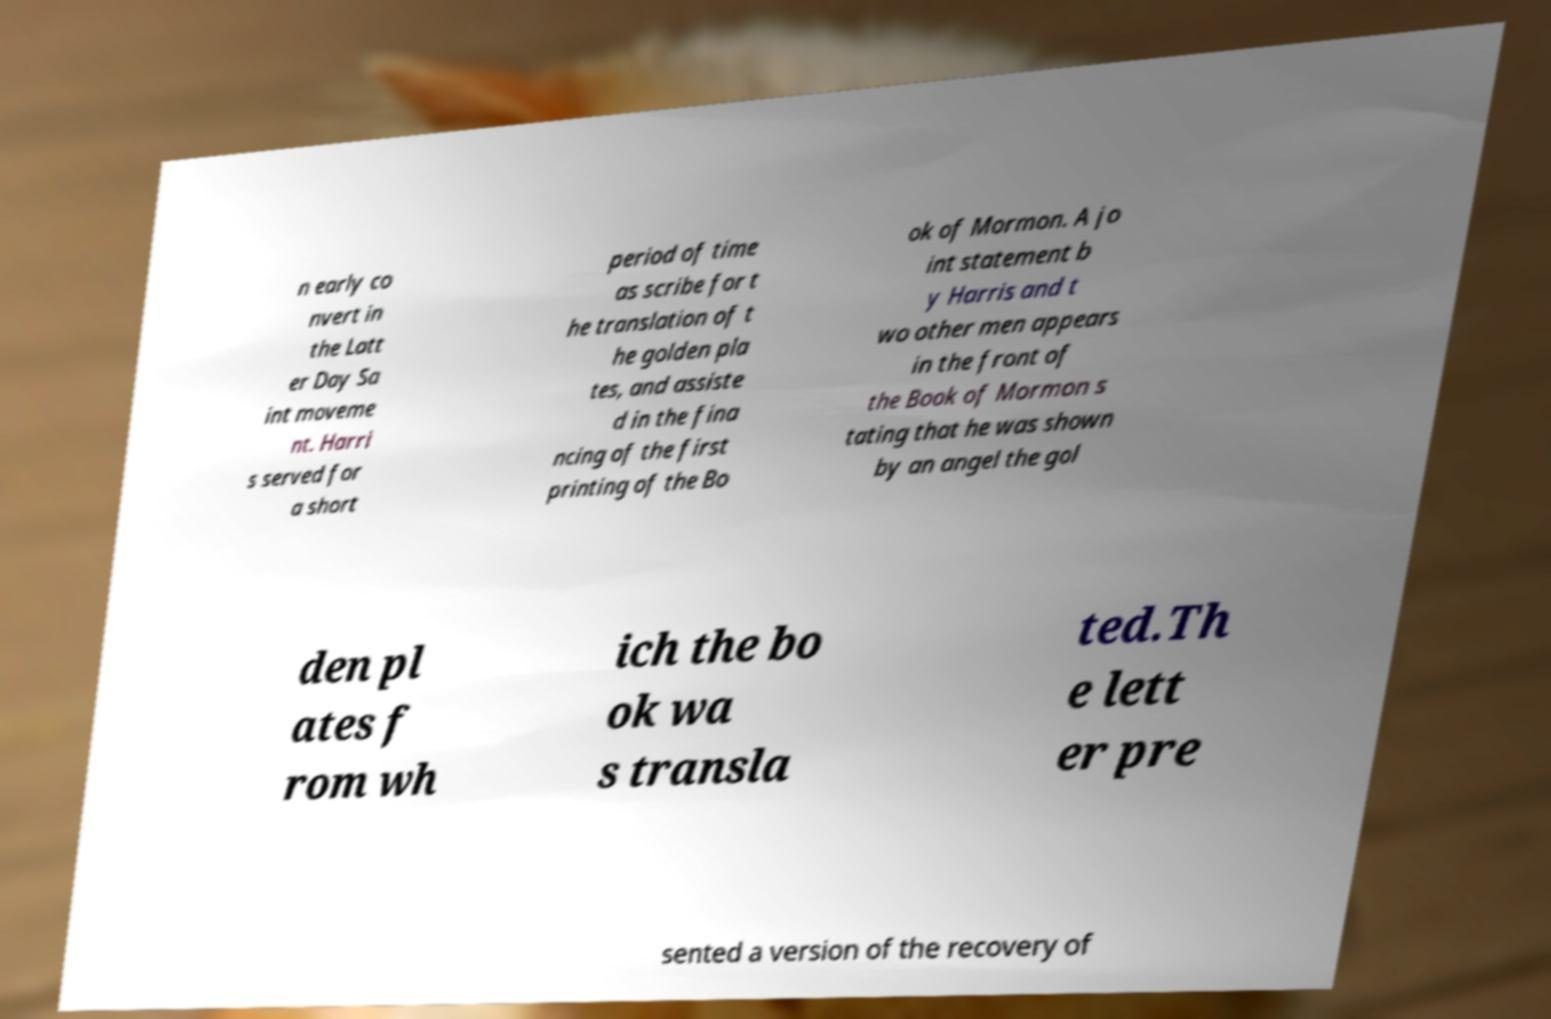For documentation purposes, I need the text within this image transcribed. Could you provide that? n early co nvert in the Latt er Day Sa int moveme nt. Harri s served for a short period of time as scribe for t he translation of t he golden pla tes, and assiste d in the fina ncing of the first printing of the Bo ok of Mormon. A jo int statement b y Harris and t wo other men appears in the front of the Book of Mormon s tating that he was shown by an angel the gol den pl ates f rom wh ich the bo ok wa s transla ted.Th e lett er pre sented a version of the recovery of 